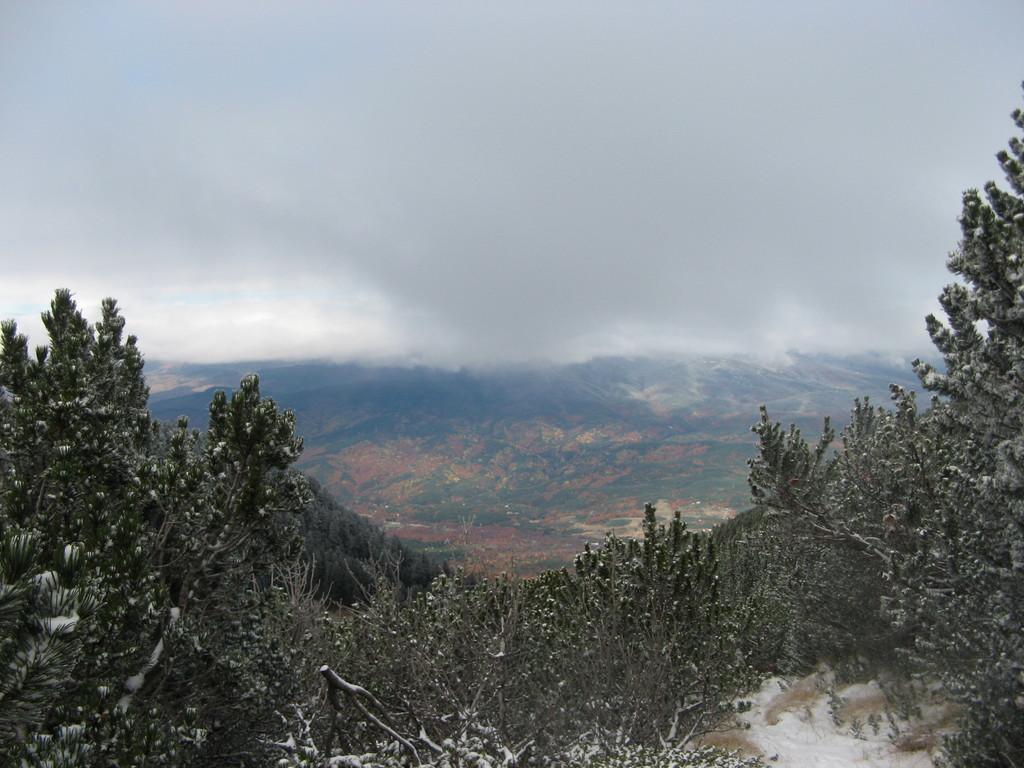In one or two sentences, can you explain what this image depicts? At the bottom of the picture, there are trees and there are hills in the background. At the top of the picture, we see the sky and this picture is clicked in the outskirts. 